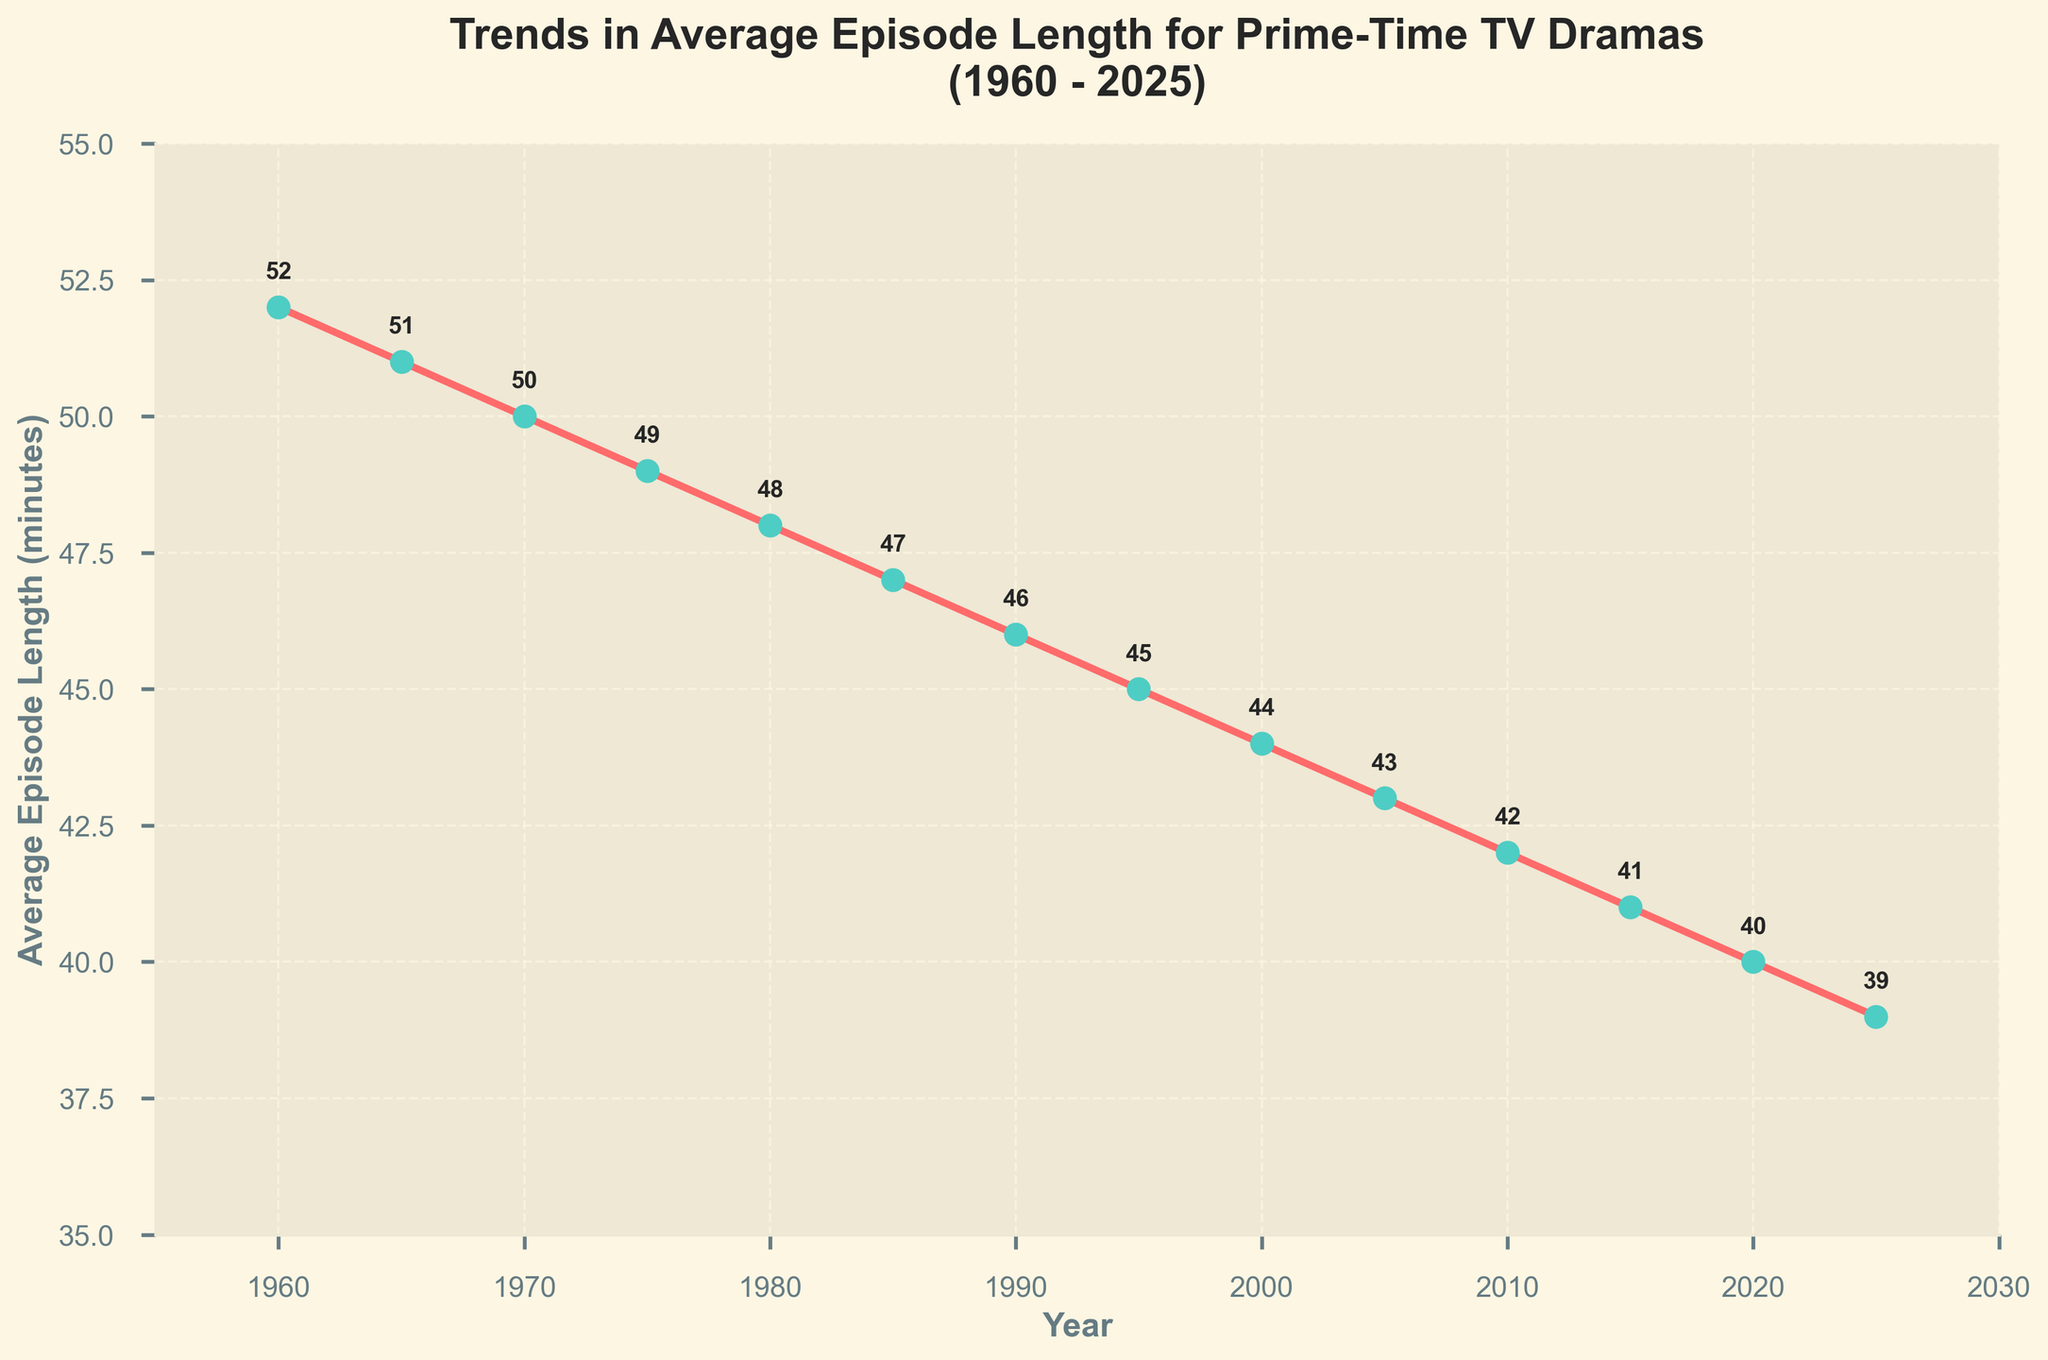What is the average episode length in 1980? By observing the data point corresponding to the year 1980 on the plot and reading its value.
Answer: 48 How many minutes did the average episode length decrease from 1960 to 2025? Subtract the average episode length in 2025 from the average episode length in 1960 (52 - 39).
Answer: 13 Did the average episode length ever increase in the time frame shown? Check if any subsequent year has a higher value than the previous one, noting that all values consistently decrease.
Answer: No Which decade saw the largest single decrease in average episode length and how much was it? Compare the differences in average episode length between each subsequent decade and identify the maximum value (e.g., 1960s to 1970s, etc.). The largest decrease is from the 1960s to the 1970s (1960: 52, 1970: 50, difference: 2 minutes).
Answer: 1960s to 1970s, 2 minutes What is the average of the episode lengths in 1960, 1980, and 2000? Add the average episode lengths for 1960 (52), 1980 (48), and 2000 (44) and then divide by 3: (52 + 48 + 44) / 3.
Answer: 48 By how many minutes did the average episode length drop from 1975 to 1985? Subtract the average episode length in 1985 from the average episode length in 1975 (49 - 47).
Answer: 2 Was the year 2015 above or below the average trend? Determine the position of the data point corresponding to 2015 relative to the trend line, noting it continues the downward trend, thus it's part of the trend.
Answer: Below What is the total decrease in average episode length from 1965 to 2015? Subtract the average episode length in 2015 from the average episode length in 1965 (51 - 41).
Answer: 10 Which year had an average episode length closest to 45 minutes? Identify the year(s) with the data point closest to 45 minutes, which is 1995.
Answer: 1995 Identify the trend observed for prime-time TV dramas' episode lengths from 1960 to 2025. Observe the plot's overall direction, noting the consistent downward trend.
Answer: Decreasing 